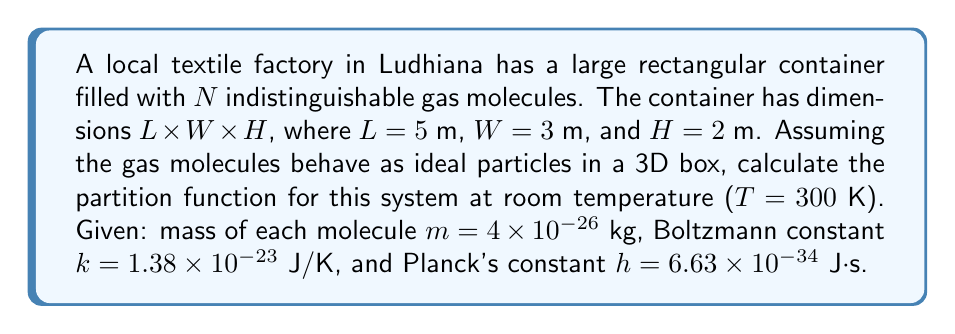Could you help me with this problem? Let's approach this step-by-step:

1) The partition function for a single particle in a 3D box is given by:

   $$Z_1 = \left(\frac{2\pi mkT}{h^2}\right)^{3/2} V$$

   where V is the volume of the box.

2) Calculate the volume:
   $$V = L \times W \times H = 5 \times 3 \times 2 = 30 \text{ m}^3$$

3) Substitute the values into the partition function equation:

   $$Z_1 = \left(\frac{2\pi (4 \times 10^{-26})(1.38 \times 10^{-23})(300)}{(6.63 \times 10^{-34})^2}\right)^{3/2} \times 30$$

4) Simplify:
   $$Z_1 = (1.56 \times 10^{31})^{3/2} \times 30 = 5.85 \times 10^{47}$$

5) For N indistinguishable particles, the total partition function is:

   $$Z = \frac{Z_1^N}{N!}$$

6) However, as N is not specified, we cannot calculate the final value. The partition function for the system of N particles in the box is:

   $$Z = \frac{(5.85 \times 10^{47})^N}{N!}$$
Answer: $Z = \frac{(5.85 \times 10^{47})^N}{N!}$ 